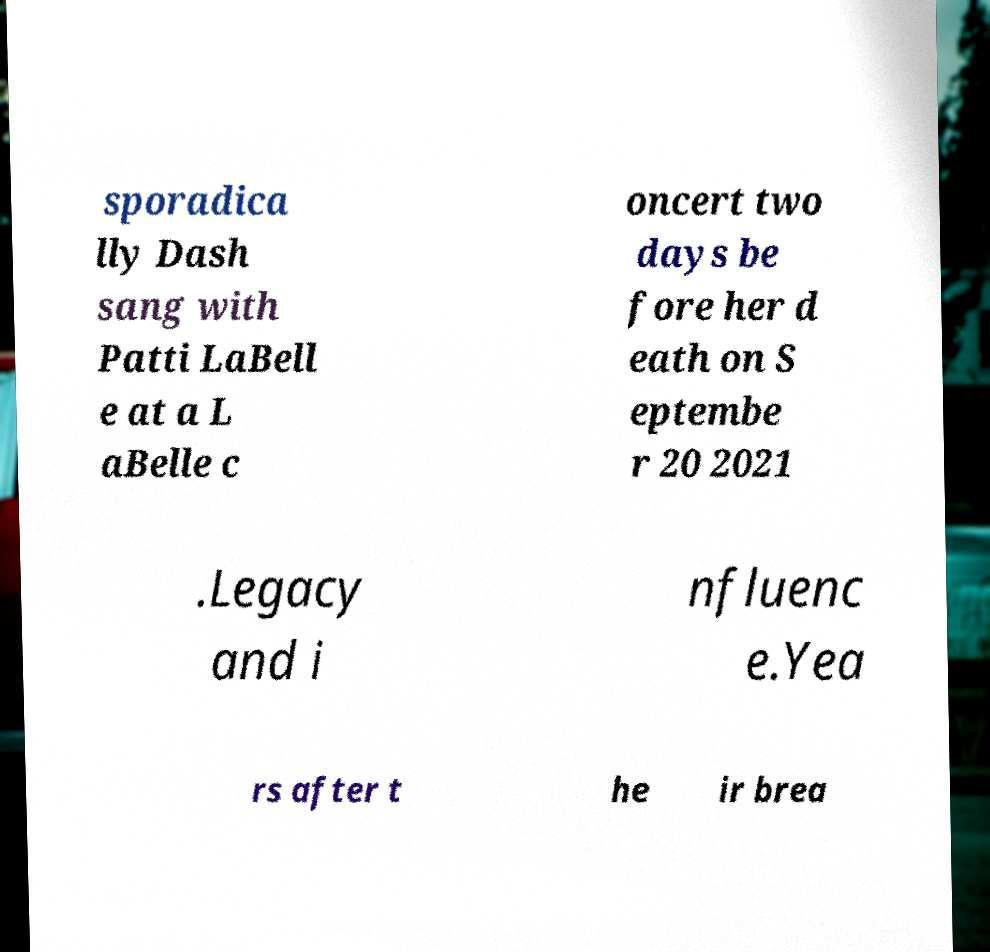For documentation purposes, I need the text within this image transcribed. Could you provide that? sporadica lly Dash sang with Patti LaBell e at a L aBelle c oncert two days be fore her d eath on S eptembe r 20 2021 .Legacy and i nfluenc e.Yea rs after t he ir brea 